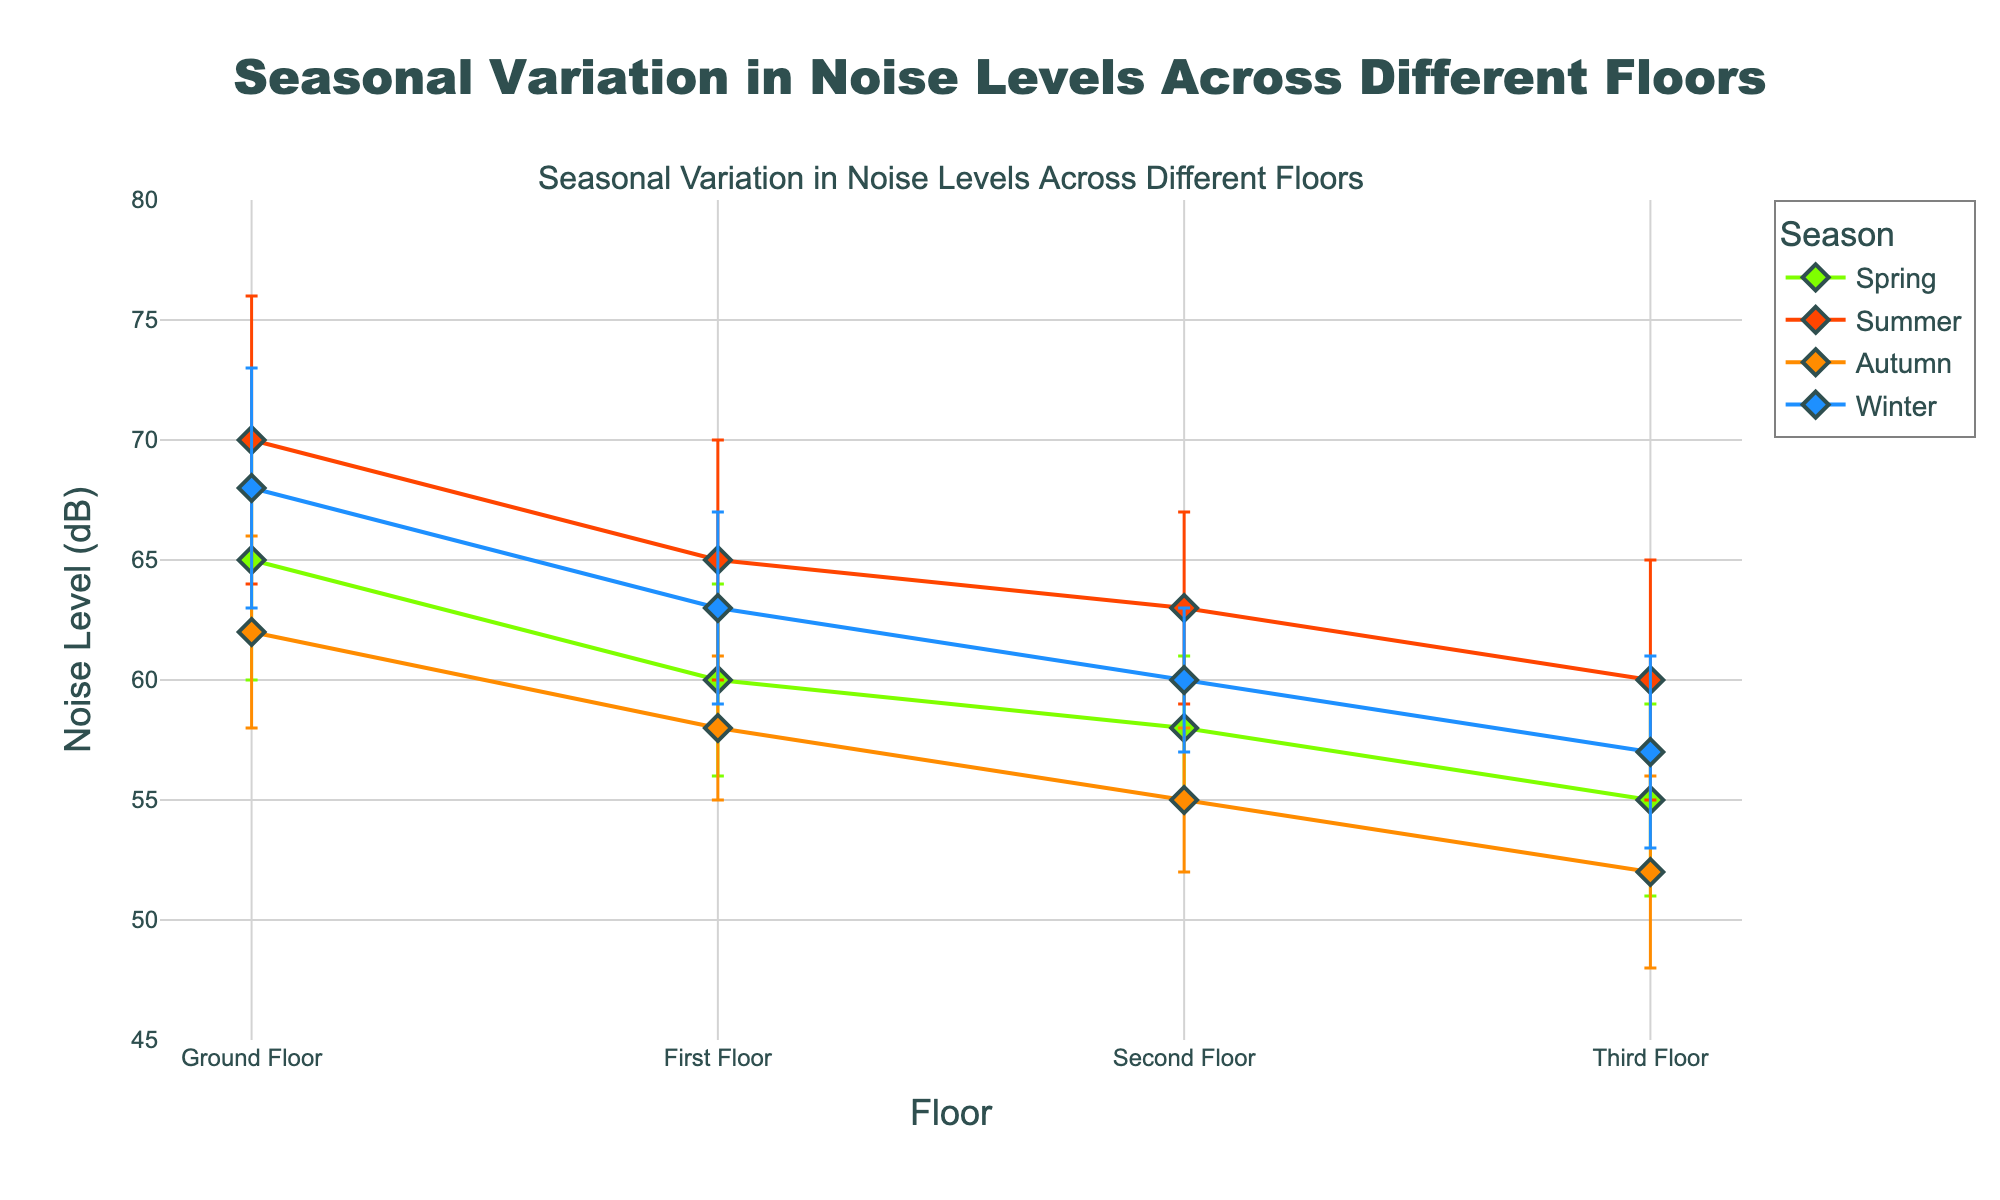what's the title of the figure? The title of the figure is typically placed at the top or in a prominent position where it's easily visible and it provides a concise summary of what's being shown in the chart. In this case, you would look at the top center of the chart.
Answer: Seasonal Variation in Noise Levels Across Different Floors how many floors are represented in the plot? To determine the number of floors represented, you can count the distinct labels on the x-axis of the plot. These labels should correspond to different floor levels.
Answer: Four which floor has the highest noise level in summer? Look at the data points connected by the line marked "Summer" and identify which data point has the highest value on the y-axis. This will show which floor has the highest noise level in that season.
Answer: Ground Floor what's the difference in noise levels between the ground floor and the third floor during winter? Identify the noise levels (y-values) for both the Ground Floor and the Third Floor during winter from the plot. Subtract the third floor value from the ground floor value.
Answer: 11 dB which season shows the greatest noise variation across different floors? Compare the error bars across seasons. The season with the largest average error bars indicates the greatest noise variation.
Answer: Summer what's the mean noise level on the first floor in autumn? Look for the data point on the "First Floor" x-axis label for the "Autumn" season. The y-value of this data point represents the mean noise level.
Answer: 58 dB which floor has the least noise variation during spring? Compare the error bars of the different floors during the spring season. The floor with the smallest error bar indicates the least noise variation.
Answer: Second Floor which season generally has the highest noise levels? To determine this, compare the noise level values (y-axis) across all seasons. Look for which season tends to have higher values.
Answer: Summer which season shows the least noise level on the second floor? Compare the data points corresponding to the "Second Floor" across all seasons and identify which season has the lowest noise level.
Answer: Autumn how consistent are noise levels on the third floor across different seasons? Observe the error bars on the third-floor data points across seasons. Consistency means smaller error bars and less fluctuation in the mean values.
Answer: Fairly consistent, with minor variation 